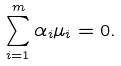Convert formula to latex. <formula><loc_0><loc_0><loc_500><loc_500>\sum _ { i = 1 } ^ { m } \alpha _ { i } \mu _ { i } = 0 .</formula> 